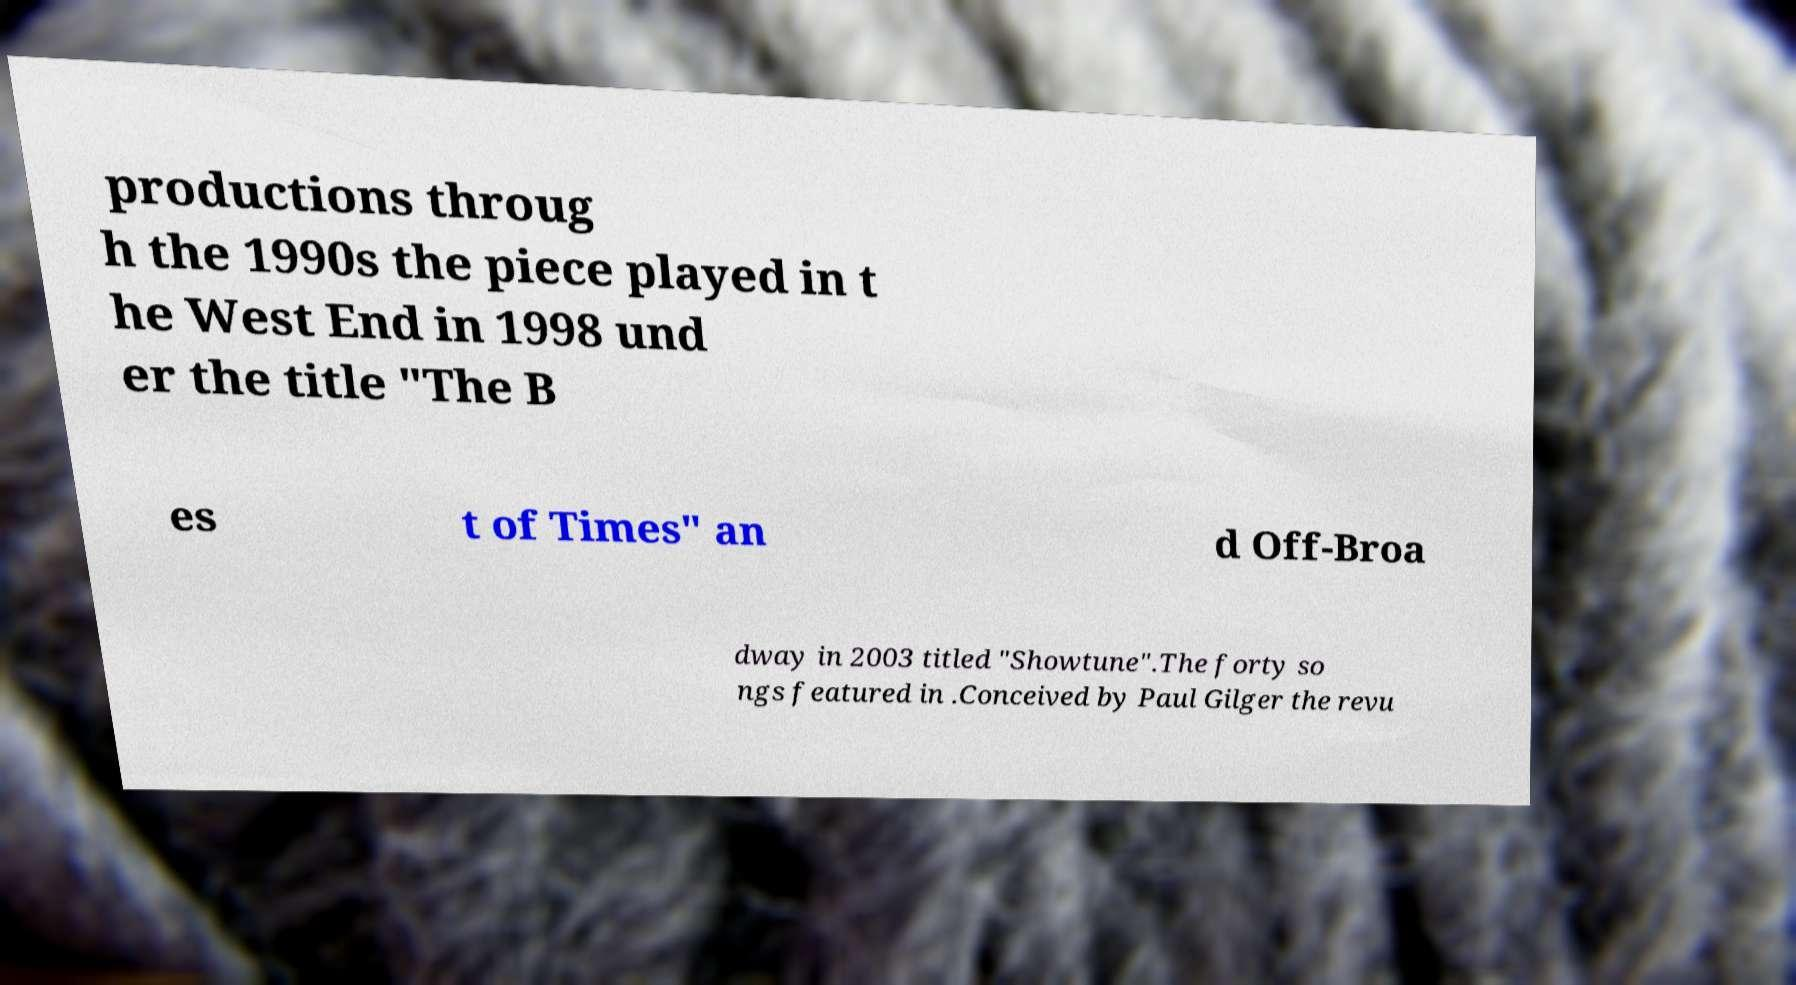Could you assist in decoding the text presented in this image and type it out clearly? productions throug h the 1990s the piece played in t he West End in 1998 und er the title "The B es t of Times" an d Off-Broa dway in 2003 titled "Showtune".The forty so ngs featured in .Conceived by Paul Gilger the revu 